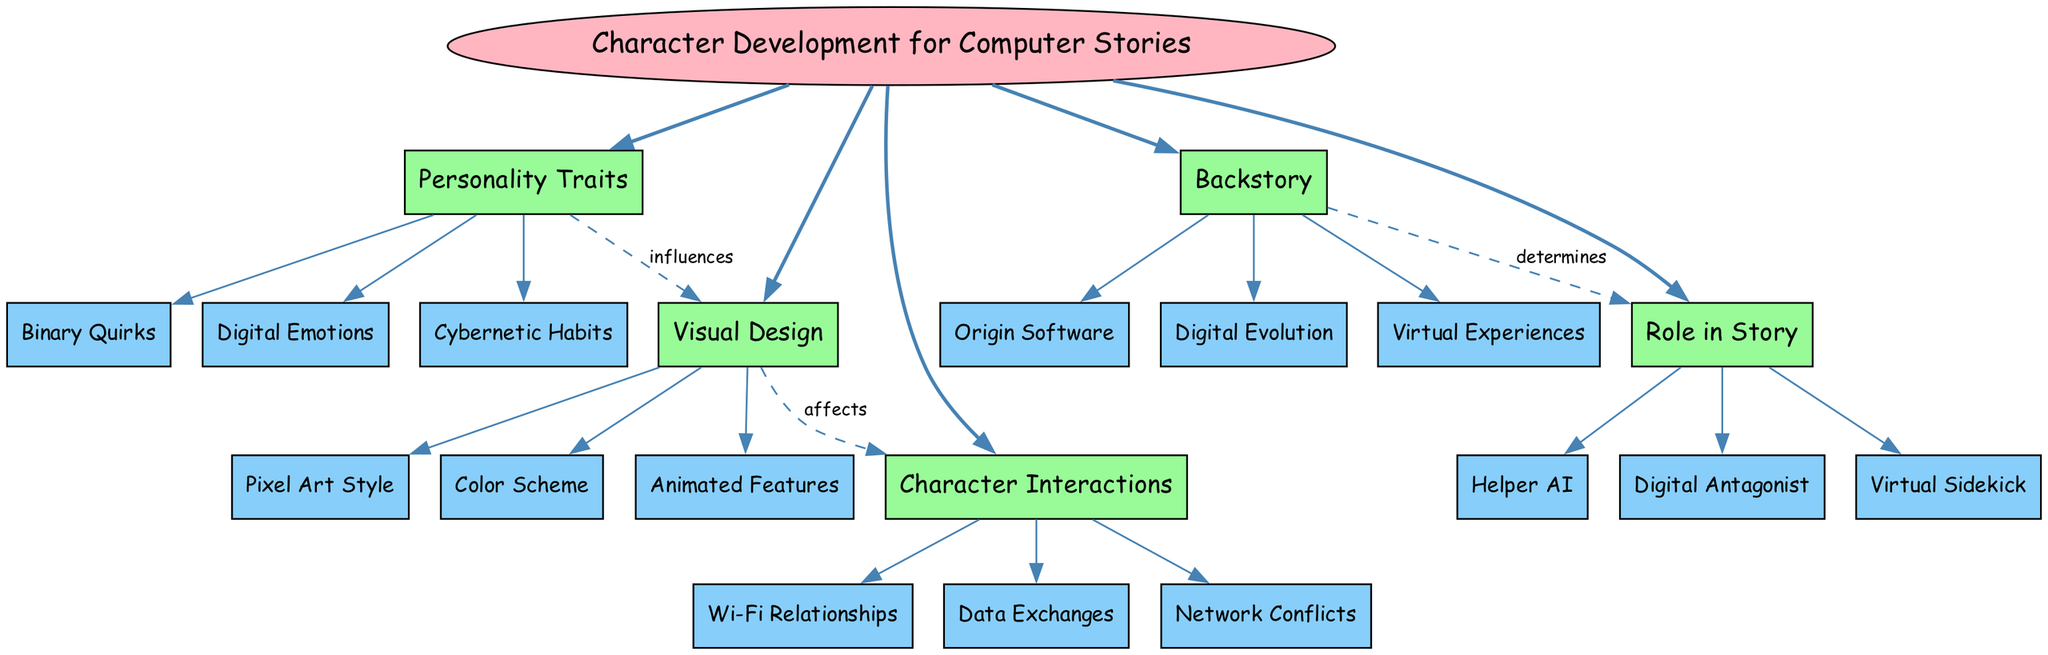What is the central concept of the diagram? The central concept node in the diagram is labeled "Character Development for Computer Stories". It is the main subject around which the entire concept map is structured.
Answer: Character Development for Computer Stories How many main branches are there in the diagram? There are five main branches identified in the diagram: Personality Traits, Visual Design, Backstory, Role in Story, and Character Interactions. This count can be verified by counting the branches stemming from the central concept.
Answer: 5 What influences Visual Design according to the diagram? The diagram shows that "Personality Traits" influences "Visual Design" through a directed edge labeled "influences". This connection indicates a relationship where personality may shape the visual representation of the characters.
Answer: Personality Traits Which sub-branch belongs to the "Backstory"? The sub-branches listed under "Backstory" include "Origin Software", "Digital Evolution", and "Virtual Experiences". Any of these could be mentioned as belonging to it, confirmed by seeing them attached under that branch.
Answer: Origin Software (or Digital Evolution, or Virtual Experiences) What determines the "Role in Story"? According to the diagram, "Backstory" determines the "Role in Story", as indicated by a directed edge with the label "determines". This means that the character's backstory is essential in shaping how they function within the narrative.
Answer: Backstory What affects Character Interactions? The relationship in the diagram indicates that "Visual Design" affects "Character Interactions", shown by an edge labeled "affects". This suggests that how a character is designed visually can influence how they interact with others in the story.
Answer: Visual Design What type of character is categorized under "Role in Story"? The "Role in Story" branch includes sub-branches such as "Helper AI", "Digital Antagonist", and "Virtual Sidekick". This identifies their specific roles within an imaginative narrative context, any of which can be an acceptable answer.
Answer: Helper AI (or Digital Antagonist, or Virtual Sidekick) How many sub-branches are listed under "Visual Design"? The branch labeled "Visual Design" contains three sub-branches: "Pixel Art Style", "Color Scheme", and "Animated Features". Counting them yields a total of three sub-branches associated with this concept.
Answer: 3 What type of relationship exists between Personality Traits and Visual Design? The diagram illustrates a dashed edge from "Personality Traits" to "Visual Design" labeled "influences", describing their connection. This indicates a type of relationship where personality aspects contribute to visual representation choices.
Answer: influences 